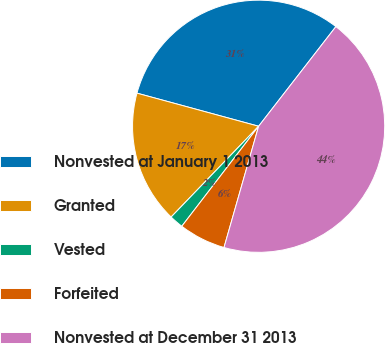<chart> <loc_0><loc_0><loc_500><loc_500><pie_chart><fcel>Nonvested at January 1 2013<fcel>Granted<fcel>Vested<fcel>Forfeited<fcel>Nonvested at December 31 2013<nl><fcel>31.27%<fcel>17.02%<fcel>1.78%<fcel>6.0%<fcel>43.93%<nl></chart> 